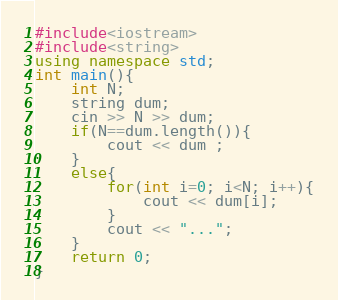<code> <loc_0><loc_0><loc_500><loc_500><_C++_>#include<iostream>
#include<string>
using namespace std;
int main(){
	int N;
	string dum;
	cin >> N >> dum;
	if(N==dum.length()){
		cout << dum ;
	}
	else{
		for(int i=0; i<N; i++){
			cout << dum[i];
		}
		cout << "...";
	}
	return 0;
}</code> 